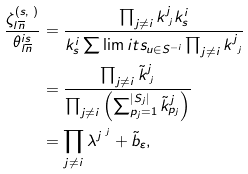<formula> <loc_0><loc_0><loc_500><loc_500>\frac { \zeta _ { l \overline { n } } ^ { ( s , \mathbf r ) } } { \theta _ { l \overline { n } } ^ { i s } } & = \frac { \prod _ { j \neq i } k ^ { j } _ { \mathbf r ^ { j } } k ^ { i } _ { s } } { k ^ { i } _ { s } \sum \lim i t s _ { u \in S ^ { - i } } \prod _ { j \neq i } k ^ { j } _ { \mathbf u ^ { j } } } \\ & = \frac { \prod _ { j \neq i } \tilde { k } ^ { j } _ { \mathbf r ^ { j } } } { \prod _ { j \neq i } \left ( \sum _ { p _ { j } = 1 } ^ { | S _ { j } | } \tilde { k } ^ { j } _ { p _ { j } } \right ) } \\ & = \prod _ { j \neq i } \lambda ^ { j \mathbf r ^ { j } } + \tilde { b } _ { \varepsilon } ,</formula> 